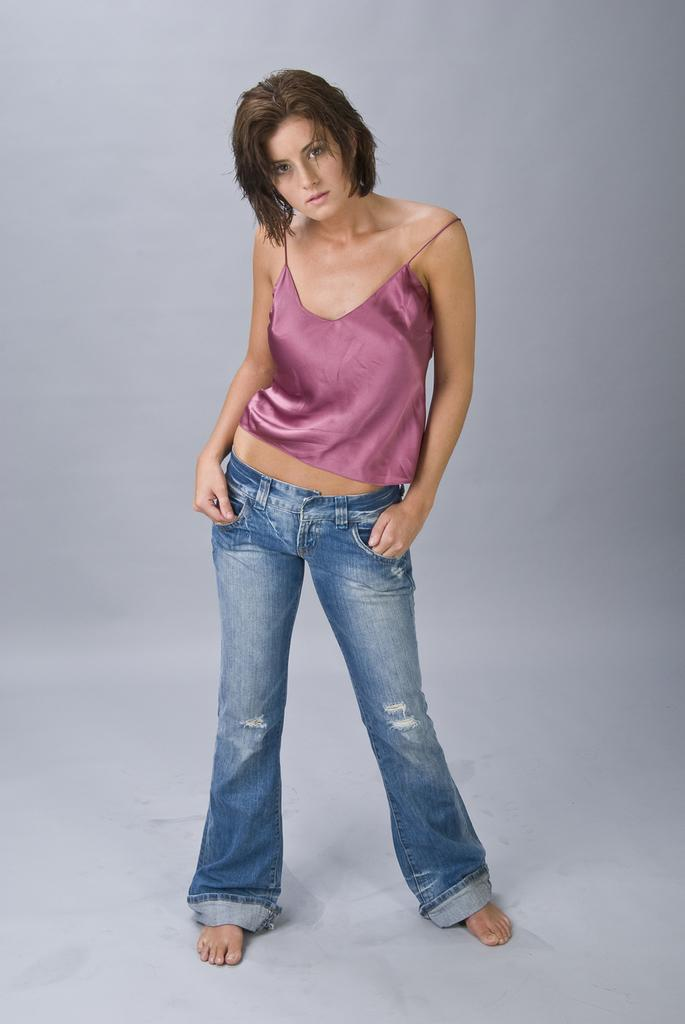Who is the main subject in the image? There is a woman in the image. What is the woman standing on? The woman is standing on a white surface. What color is the top the woman is wearing? The woman is wearing a pink top. What type of pants is the woman wearing? The woman is wearing jeans. What type of hook can be seen on the woman's pink top in the image? There is no hook visible on the woman's pink top in the image. What is the woman's desire in the image? There is no indication of the woman's desires in the image. 